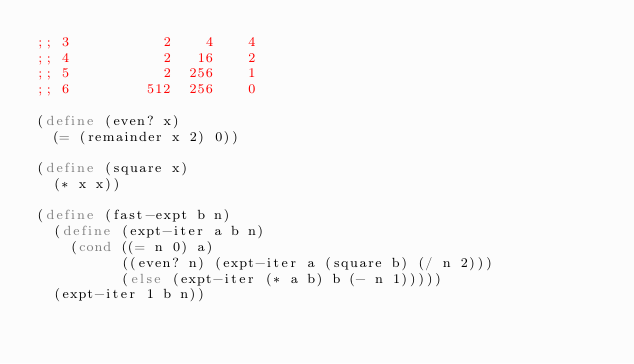Convert code to text. <code><loc_0><loc_0><loc_500><loc_500><_Scheme_>;; 3           2    4    4
;; 4           2   16    2
;; 5           2  256    1
;; 6         512  256    0

(define (even? x)
  (= (remainder x 2) 0))

(define (square x)
  (* x x))

(define (fast-expt b n)
  (define (expt-iter a b n)
    (cond ((= n 0) a)
          ((even? n) (expt-iter a (square b) (/ n 2)))
          (else (expt-iter (* a b) b (- n 1)))))
  (expt-iter 1 b n))

</code> 